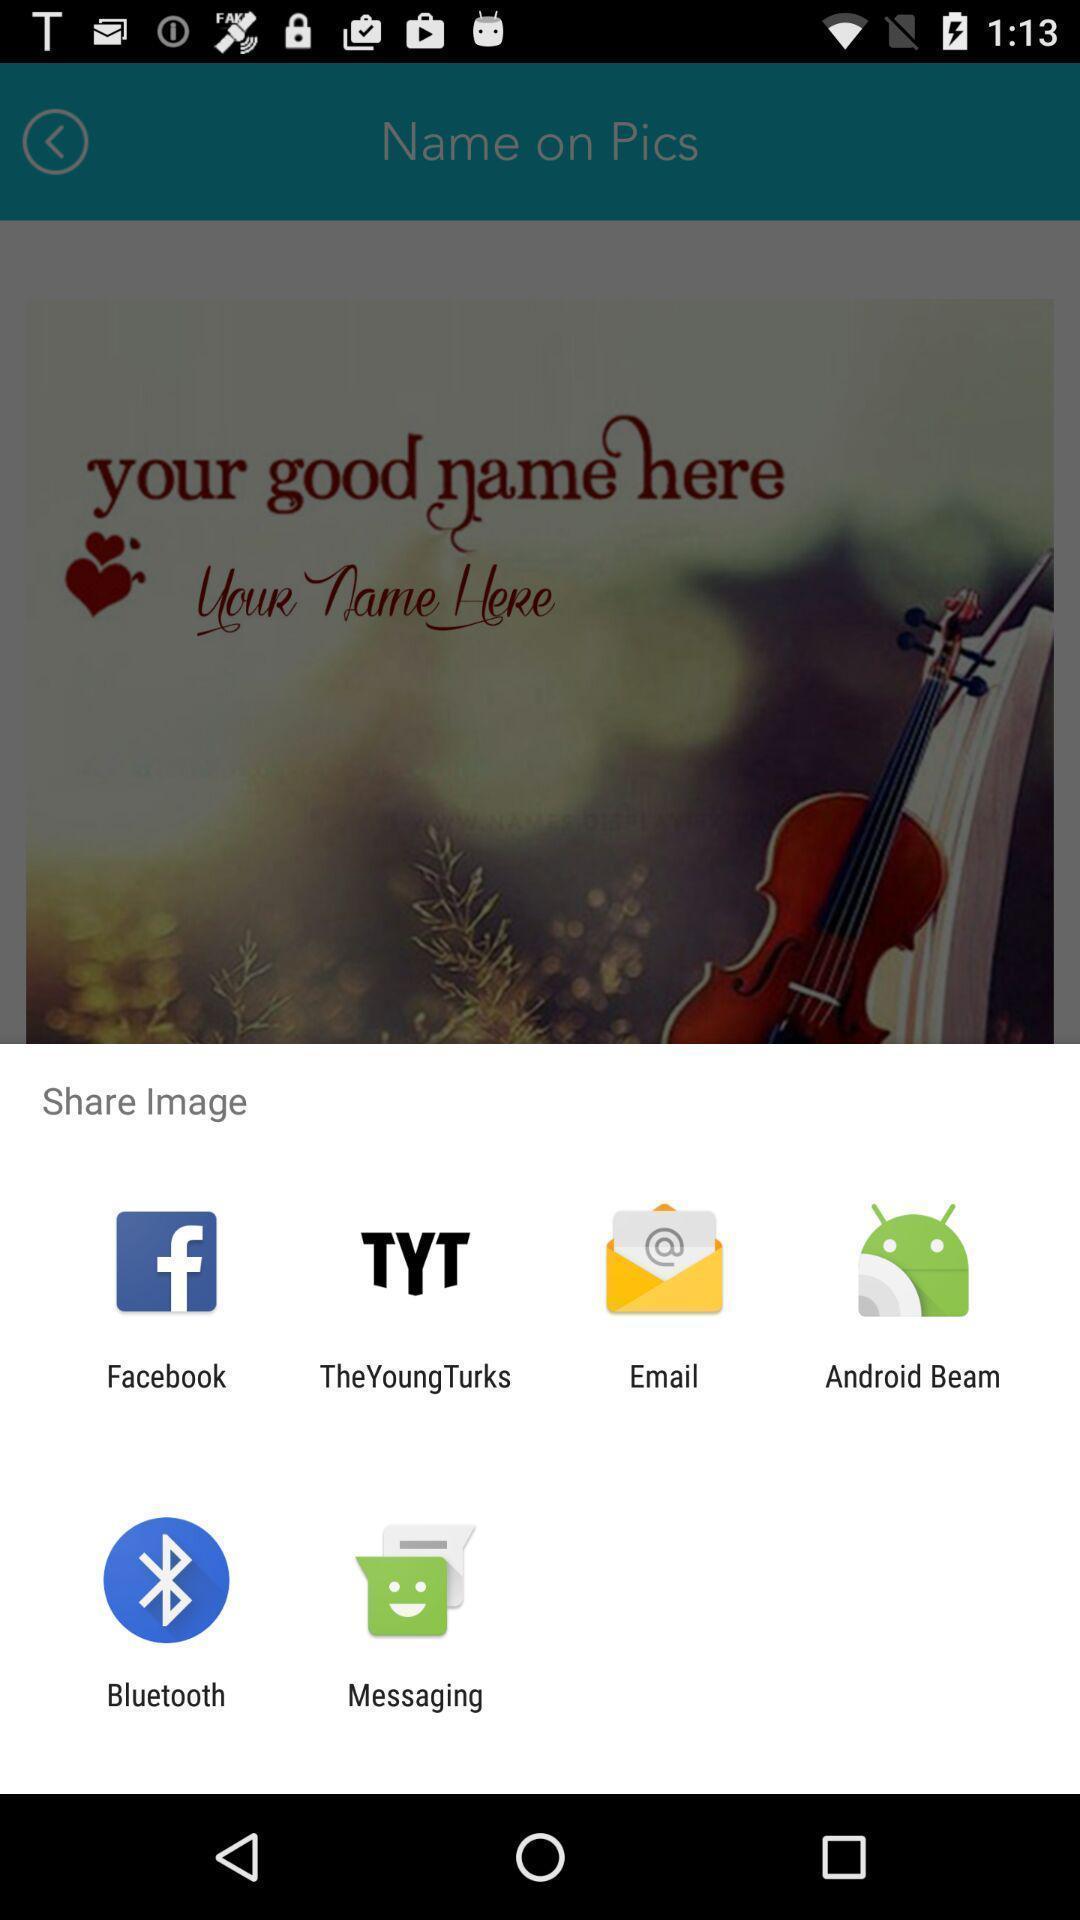Give me a narrative description of this picture. Screen showing various applications to share an image. 